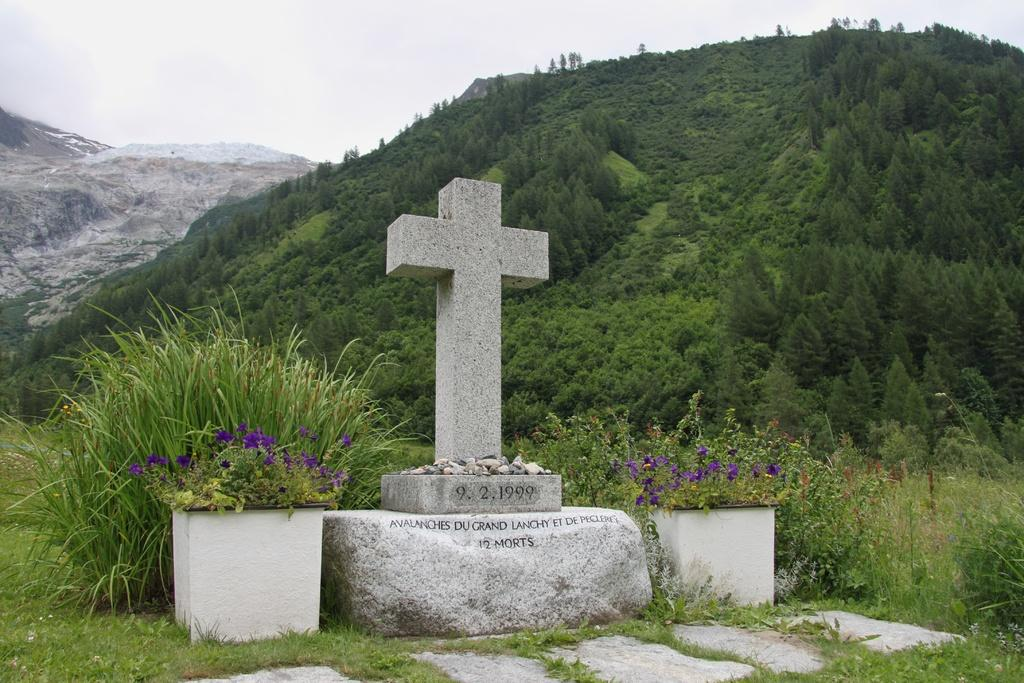What is the main subject in the center of the image? There is a memorial in the center of the image. What can be seen near the memorial? There are flower pots in the image. What is visible in the background of the image? There are mountains in the background of the image. What type of vegetation is present in the image? There are trees in the image. What type of cherry patch can be seen near the memorial in the image? There is no cherry patch present in the image. 